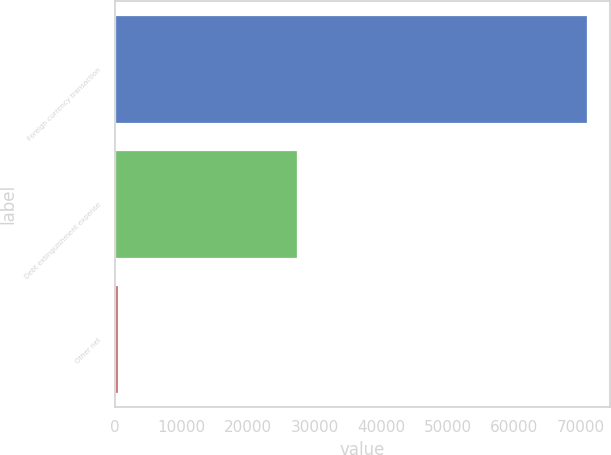Convert chart. <chart><loc_0><loc_0><loc_500><loc_500><bar_chart><fcel>Foreign currency transaction<fcel>Debt extinguishment expense<fcel>Other net<nl><fcel>70851<fcel>27305<fcel>434<nl></chart> 